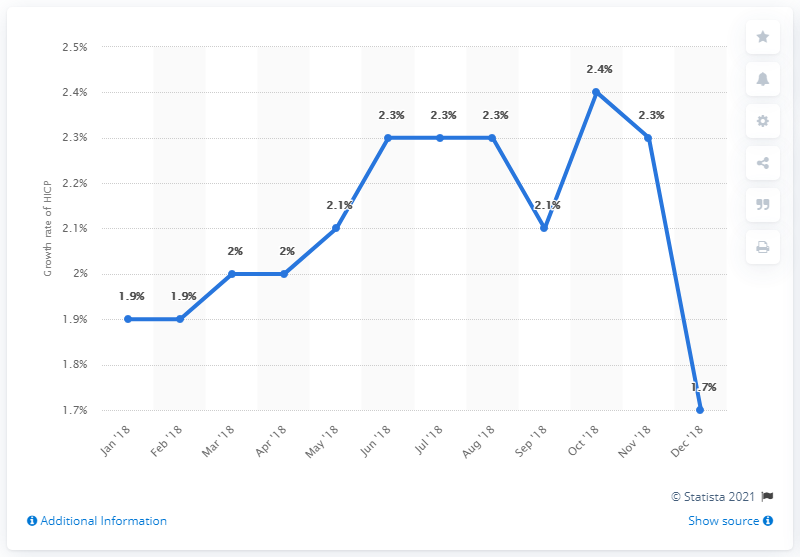Mention a couple of crucial points in this snapshot. In December 2018, the inflation rate was 1.7%. 